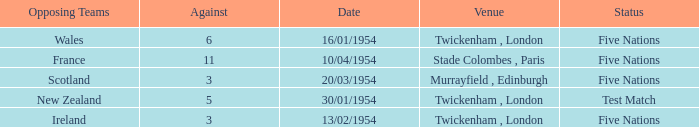What was the venue for the game played on 16/01/1954, when the against was more than 3? Twickenham , London. Parse the full table. {'header': ['Opposing Teams', 'Against', 'Date', 'Venue', 'Status'], 'rows': [['Wales', '6', '16/01/1954', 'Twickenham , London', 'Five Nations'], ['France', '11', '10/04/1954', 'Stade Colombes , Paris', 'Five Nations'], ['Scotland', '3', '20/03/1954', 'Murrayfield , Edinburgh', 'Five Nations'], ['New Zealand', '5', '30/01/1954', 'Twickenham , London', 'Test Match'], ['Ireland', '3', '13/02/1954', 'Twickenham , London', 'Five Nations']]} 